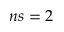Convert formula to latex. <formula><loc_0><loc_0><loc_500><loc_500>n s = 2</formula> 